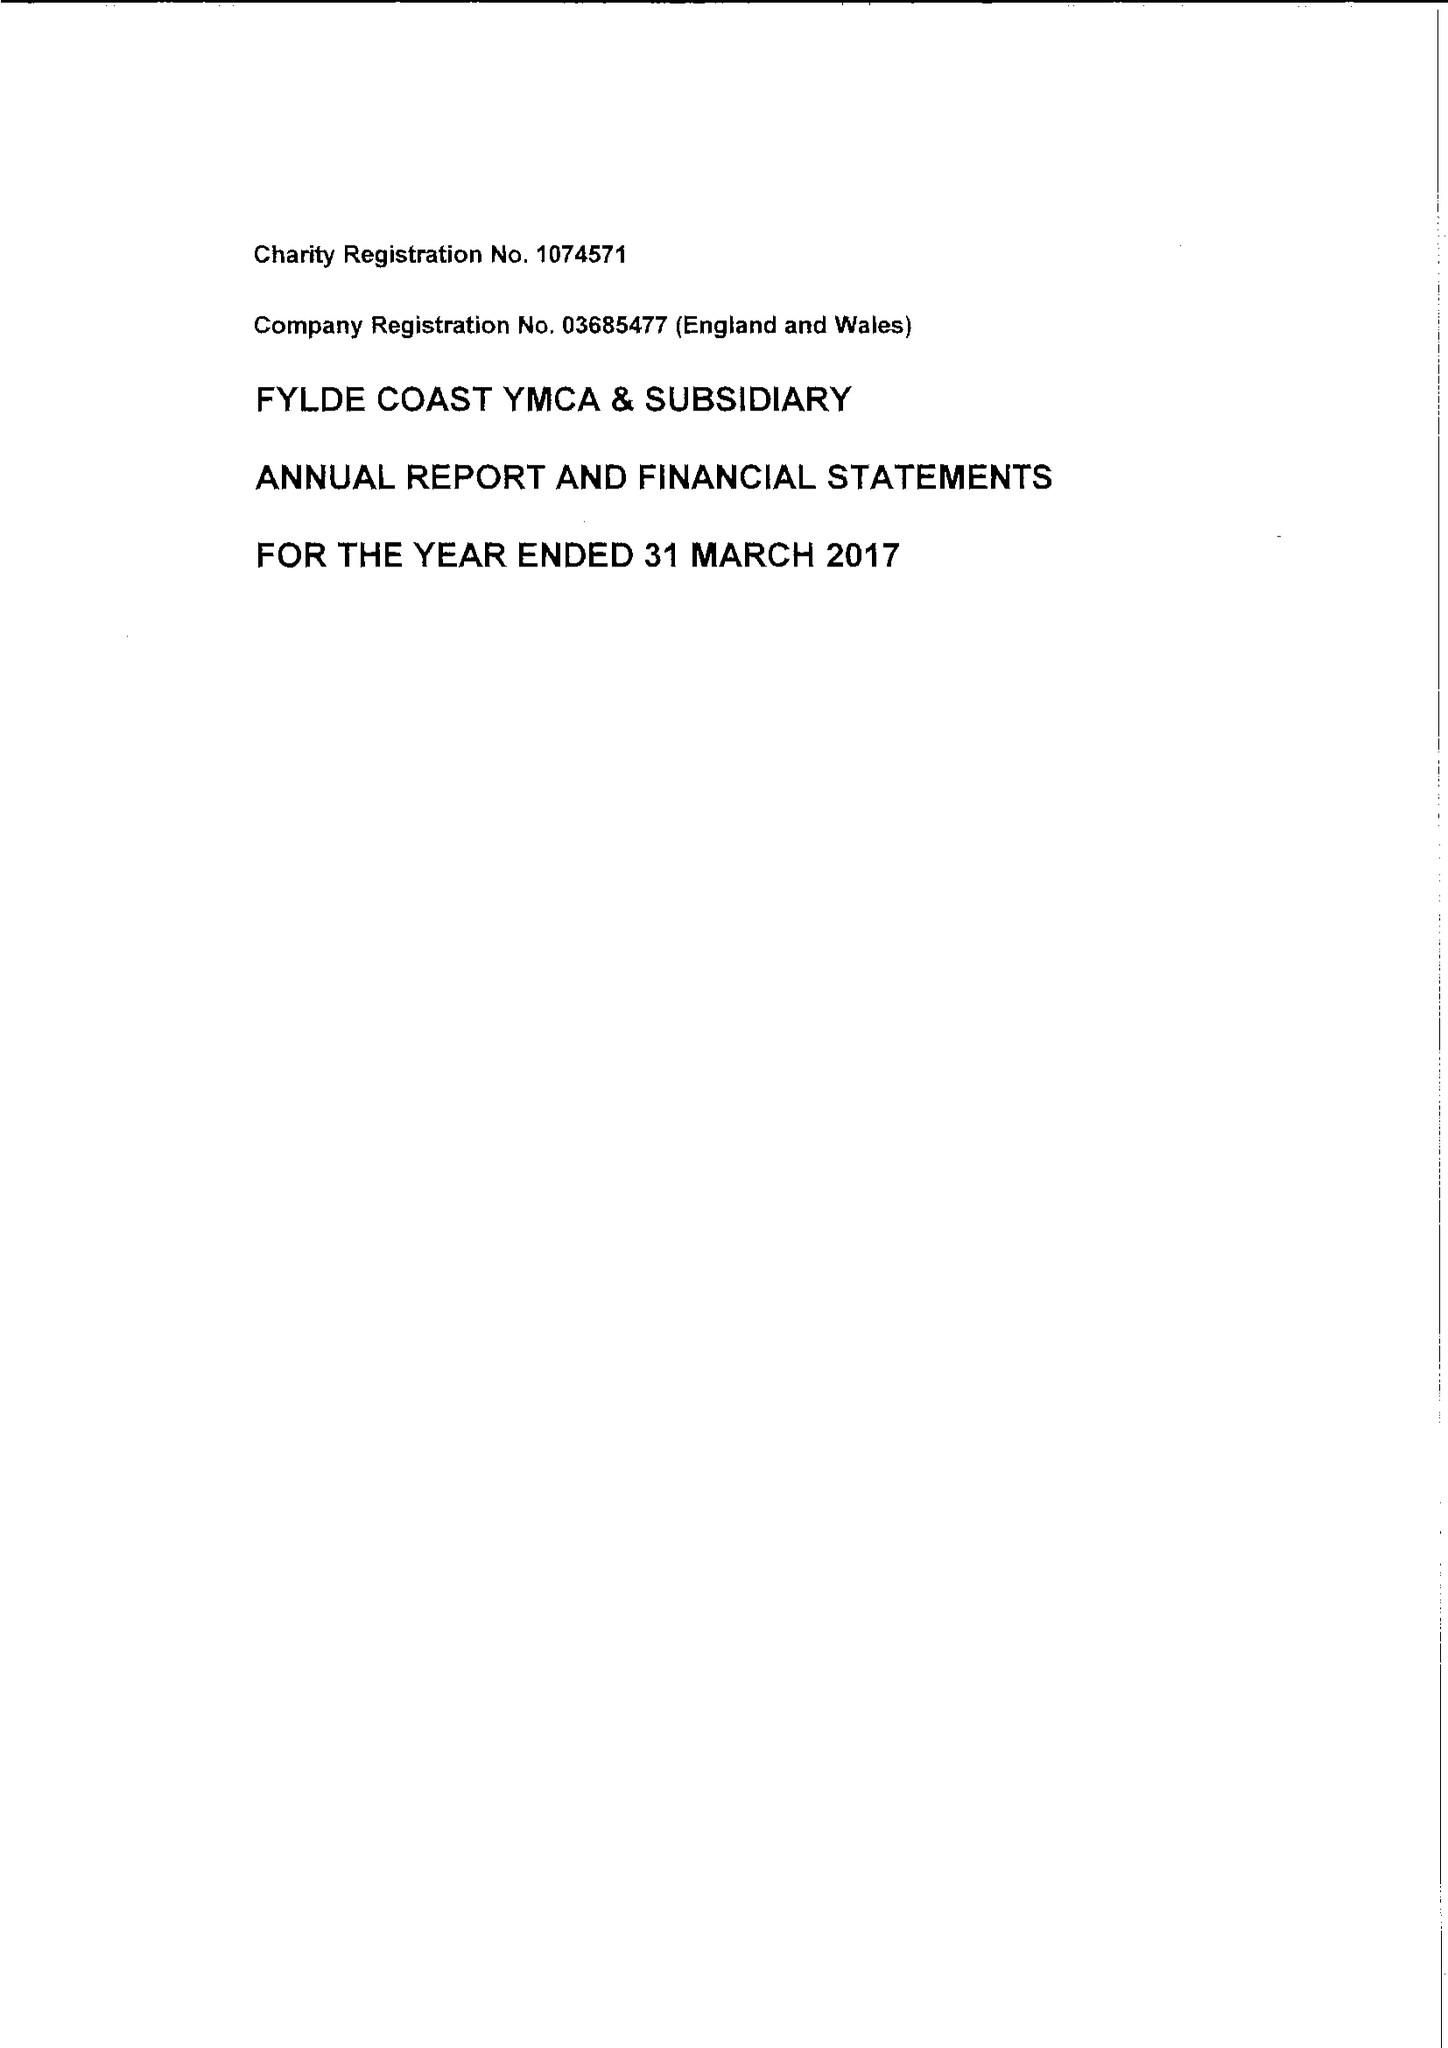What is the value for the charity_number?
Answer the question using a single word or phrase. 1074571 